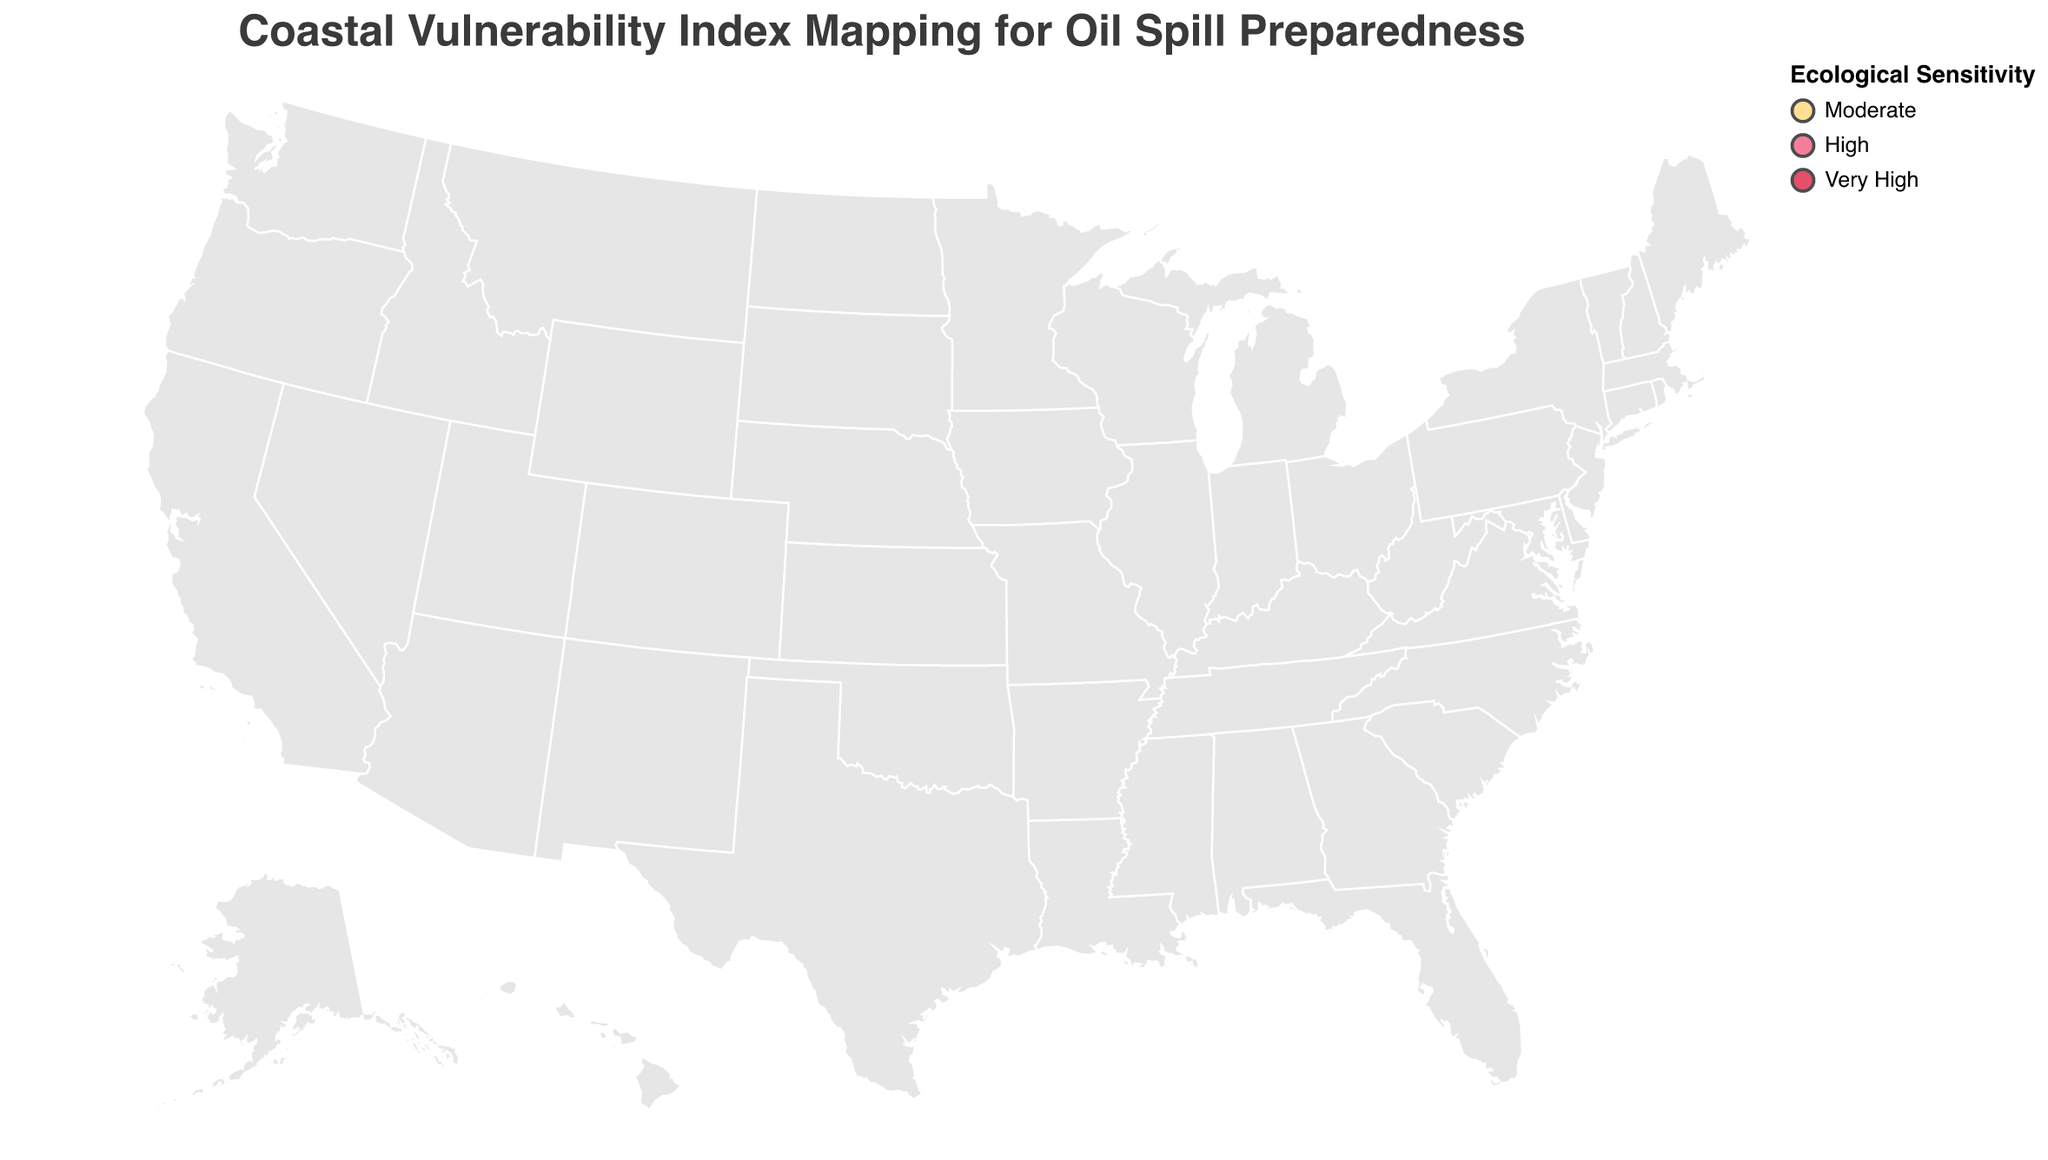How many locations are marked as "Very High" ecological sensitivity? The legend indicates the color representing "Very High" sensitivity. Count the circles of that color on the map.
Answer: 6 Which location has the highest Coastal Vulnerability Index? Find the largest data point (circle) on the map. The tooltip provides the Coastal Vulnerability Index when hovering over the circles.
Answer: Mississippi Delta What is the primary risk factor for Virginia Beach? Locate Virginia Beach on the map and hover over to see the details in the tooltip.
Answer: Tourism Impact Compare the Coastal Vulnerability Index of Miami Beach and Galveston Island. Locate both Miami Beach and Galveston Island on the map, then hover over each one to see their vulnerability indices in the tooltip.
Answer: Miami Beach: 8.9, Galveston Island: 8.1 Which regions have a Coastal Vulnerability Index above 8? Hover over each point to read the vulnerability indices. Identify those above 8.
Answer: Mississippi Delta, Miami Beach, Galveston Island, Assateague Island Order the locations with "High" ecological sensitivity from highest to lowest Coastal Vulnerability Index. Find all locations with "High" sensitivity using the color legend. Use the tooltip to get their indices and then order them.
Answer: Nantucket Island (7.8), Jacksonville Beaches (7.3), Santa Monica Bay (6.8), Acadia National Park (6.7), Olympic National Park (5.6), Puget Sound (5.9) Identify the primary risk factor for the location with the lowest Coastal Vulnerability Index. Find the smallest circle on the map. Hover to see details in the tooltip for the primary risk factor.
Answer: Oil Tanker Traffic What is the average Coastal Vulnerability Index for locations with "Moderate" ecological sensitivity? Sum the Coastal Vulnerability Indices of all "Moderate" sensitivity locations and divide by their count. (6.2 [Long Beach] + 7.5 [Virginia Beach] + 4.8 [Sitka Sound]) / 3
Answer: 6.2 